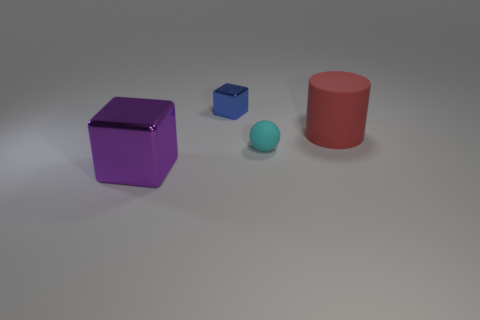Subtract all red spheres. Subtract all green cylinders. How many spheres are left? 1 Add 3 metal objects. How many objects exist? 7 Subtract all balls. How many objects are left? 3 Subtract all tiny red rubber spheres. Subtract all big purple things. How many objects are left? 3 Add 1 blue cubes. How many blue cubes are left? 2 Add 4 green blocks. How many green blocks exist? 4 Subtract 0 blue cylinders. How many objects are left? 4 